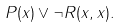<formula> <loc_0><loc_0><loc_500><loc_500>P ( x ) \vee \neg R ( x , x ) .</formula> 